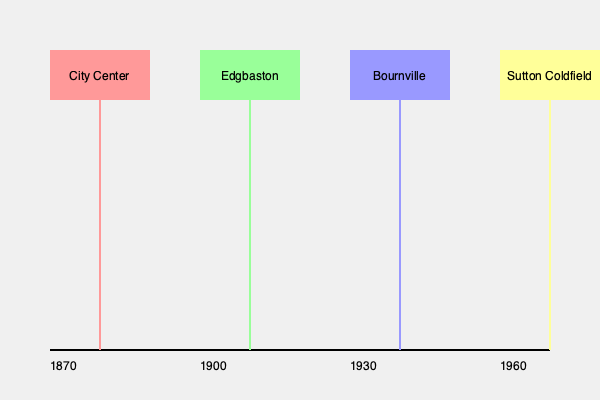Based on the timeline of Birmingham's neighborhood development shown in the graphic, which area was likely the last to be incorporated into the city, and approximately when did this occur? To answer this question, we need to analyze the timeline of Birmingham's neighborhood development as depicted in the graphic:

1. The timeline spans from 1870 to 1960, showing the development of four key neighborhoods.

2. Each neighborhood is represented by a colored rectangle and a vertical line extending to the timeline:
   - City Center (red): Appears at the beginning of the timeline, around 1870
   - Edgbaston (green): Shown developing around 1900
   - Bournville (blue): Indicated as developing around 1930
   - Sutton Coldfield (yellow): Positioned at the end of the timeline, near 1960

3. The position of each neighborhood on the timeline suggests the approximate period of its significant development or incorporation into Birmingham.

4. Sutton Coldfield, being the rightmost on the timeline, is depicted as the most recent addition to Birmingham's urban area.

5. The timeline shows Sutton Coldfield's development occurring around 1960, which is the latest date shown.

Therefore, based on this graphic representation, Sutton Coldfield appears to be the last area incorporated into Birmingham, with this occurring around 1960.
Answer: Sutton Coldfield, circa 1960 